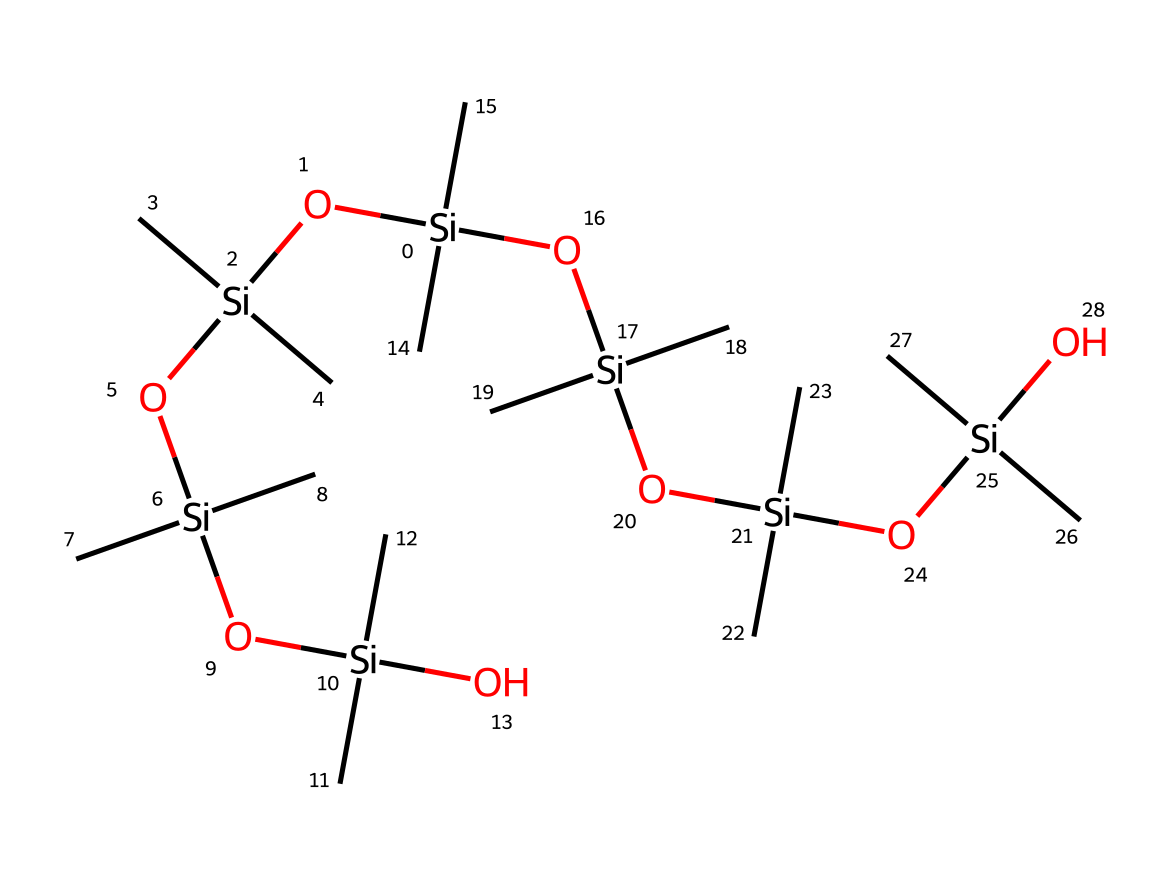What is the central atom in this compound? The structure prominently features silicon atoms connected to various other atoms, indicating that silicon is the central atom in the compound.
Answer: silicon How many total silicon atoms are present? By analyzing the SMILES representation, we count a total of six silicon atoms interlinked within the structure, which can be confirmed through the notation.
Answer: six What type of functional groups are present in this structure? The SMILES indicates multiple hydroxyl groups (–OH) connected to the silicon atoms, suggesting that the compound contains silanol groups, which are typical for silicone sealants.
Answer: silanol What is the degree of branching in this molecule? The structure shows multiple branching points due to the presence of multiple methyl groups (–C) attached to each silicon atom, indicating a highly branched structure.
Answer: highly branched How many oxygen atoms are in this chemical? When we survey the SMILES specification, we identify that there are a total of five oxygen atoms in the structure, each connected to various silicon parts.
Answer: five Why are silicone sealants ideal for marine applications? Silicone sealants possess excellent flexibility, water resistance, and adhesion properties due to their unique composition of silicon-oxygen linkages, making them suitable for sealing applications in marine environments.
Answer: flexibility and water resistance What property of this compound allows it to withstand varying temperatures? The silicon-oxygen bonds in the structure enable the compound to maintain stability and flexibility over a wide range of temperatures, contributing to its thermal stability in harsh conditions.
Answer: thermal stability 